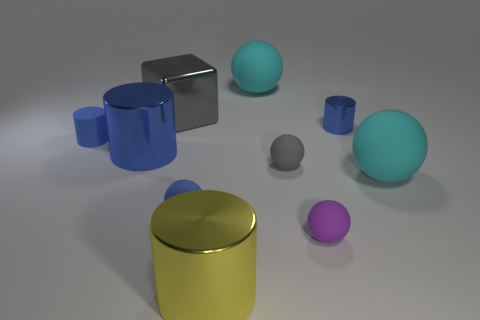Subtract all blue cubes. How many blue cylinders are left? 3 Subtract all small gray balls. How many balls are left? 4 Subtract all blue balls. How many balls are left? 4 Subtract all yellow balls. Subtract all yellow cubes. How many balls are left? 5 Subtract all cubes. How many objects are left? 9 Subtract all green things. Subtract all large gray metal objects. How many objects are left? 9 Add 9 small metal things. How many small metal things are left? 10 Add 7 tiny gray objects. How many tiny gray objects exist? 8 Subtract 0 gray cylinders. How many objects are left? 10 